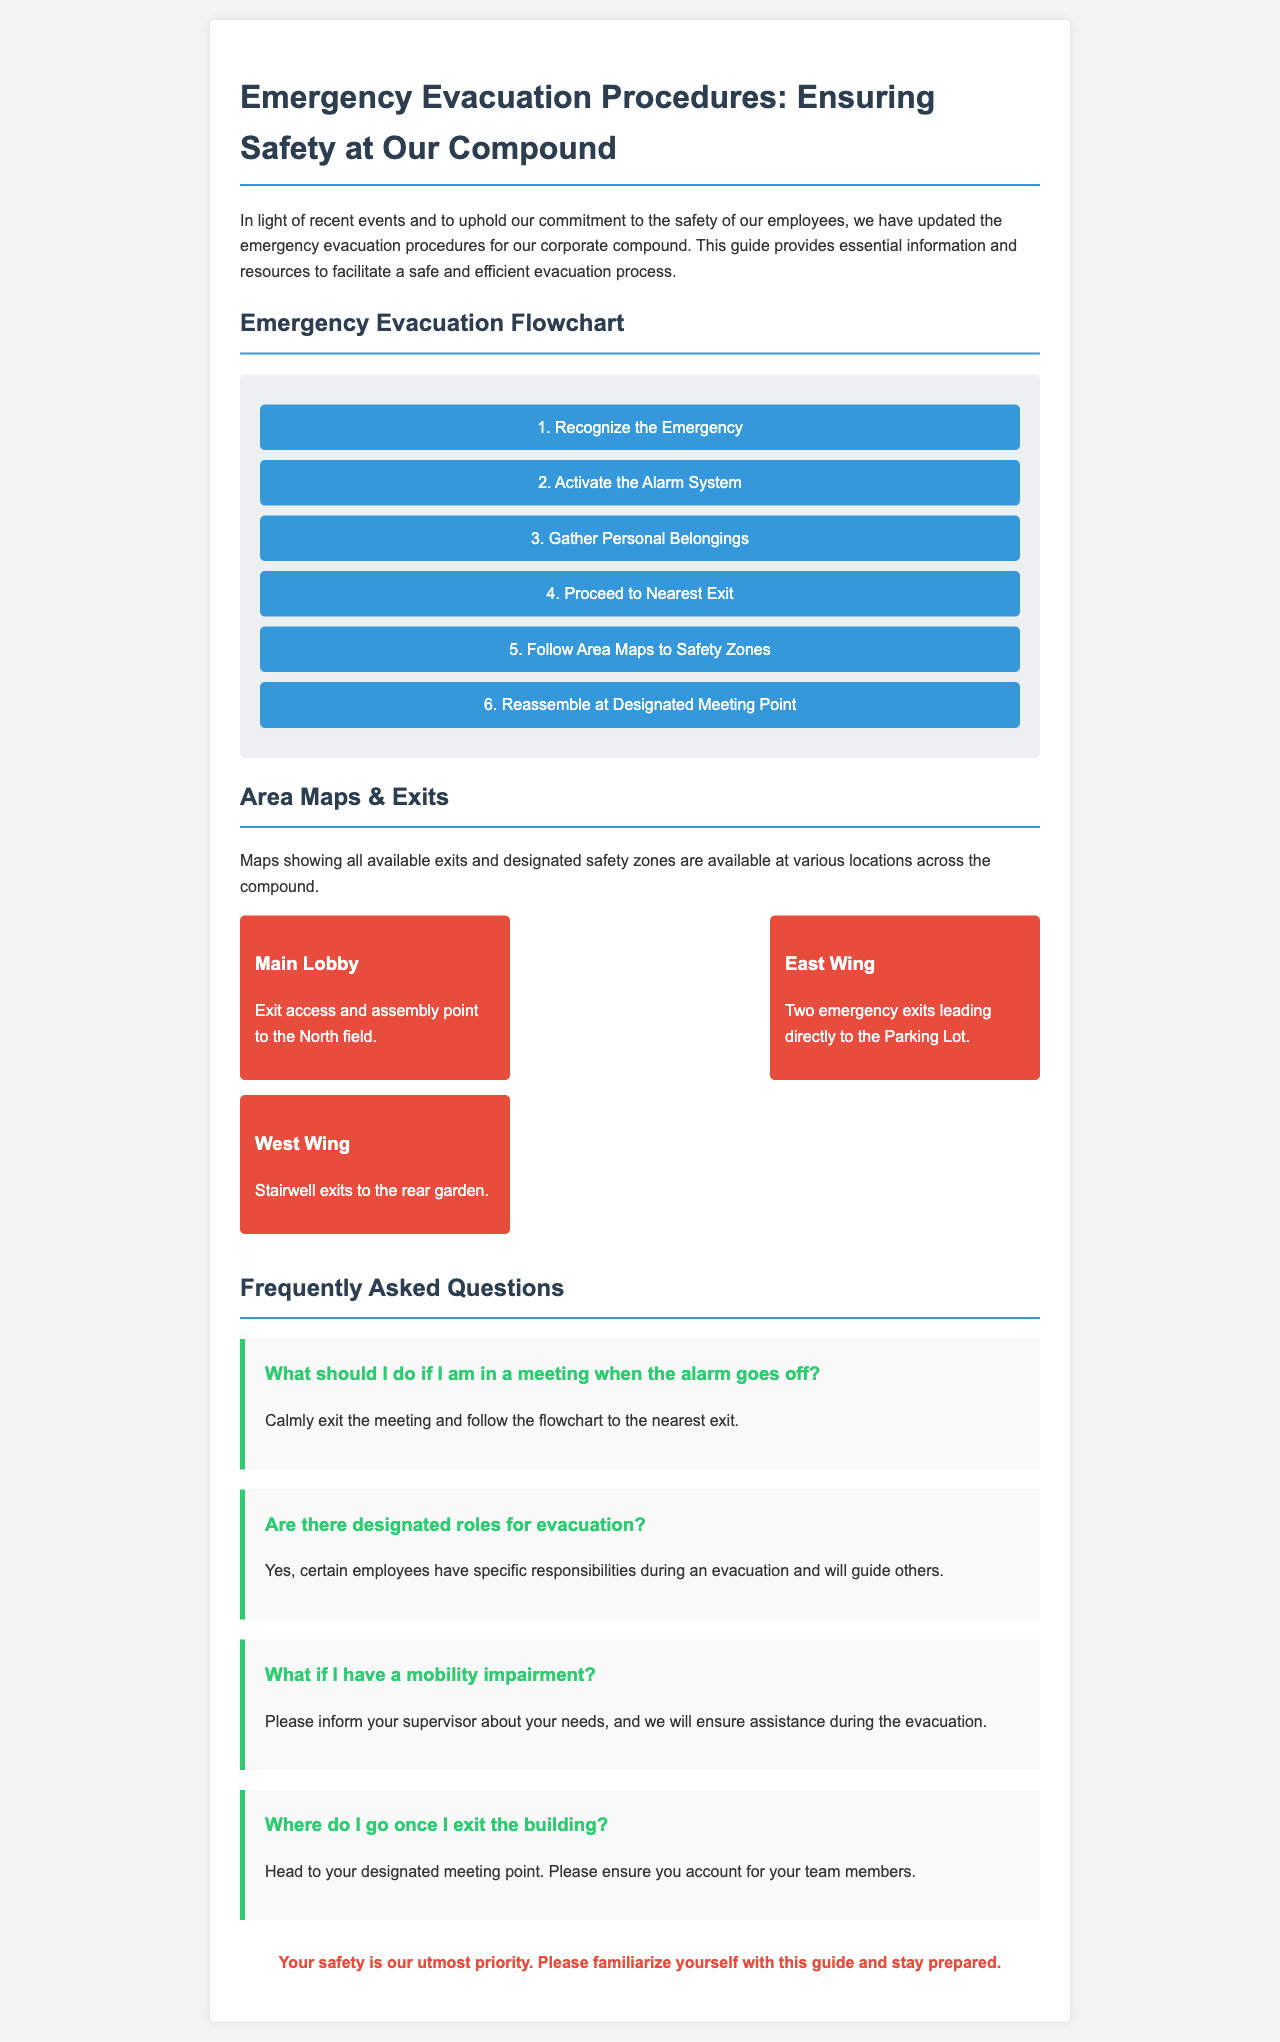What is the title of the document? The title is clearly stated in the header of the document, which is "Emergency Evacuation Procedures: Ensuring Safety at Our Compound."
Answer: Emergency Evacuation Procedures: Ensuring Safety at Our Compound What is the first step in the emergency evacuation flowchart? The first step is listed at the top of the flowchart section, which is "Recognize the Emergency."
Answer: Recognize the Emergency How many emergency exits are in the East Wing? The East Wing section specifies that there are "Two emergency exits leading directly to the Parking Lot."
Answer: Two What should you do if you are in a meeting when the alarm goes off? The document provides guidance in the FAQ section stating, "Calmly exit the meeting and follow the flowchart to the nearest exit."
Answer: Calmly exit the meeting Where are the maps showing exits located? The document states that "Maps showing all available exits and designated safety zones are available at various locations across the compound."
Answer: Various locations across the compound What color is the flowchart background? The background color of the flowchart is described in the styling of the document, noted as "background-color: #ecf0f1."
Answer: Light grey What color represents the emergency exit location in the West Wing? The document details the West Wing's exit area indicating it is represented as, "Stairwell exits to the rear garden," without a specific color but it does describe the exits.
Answer: Rear garden What is the final statement regarding safety in the document? The document concludes with a strong emphasis on safety, stated as "Your safety is our utmost priority."
Answer: Your safety is our utmost priority Who should be informed if you have a mobility impairment? The FAQ section advises to "Please inform your supervisor about your needs."
Answer: Supervisor 